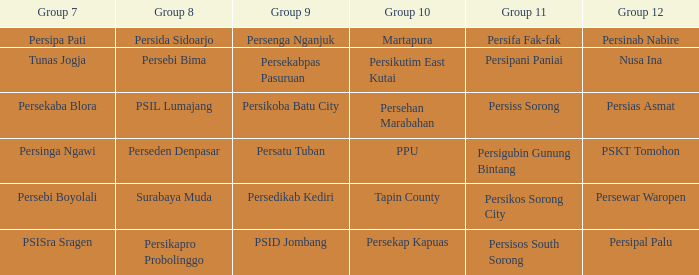When  persikos sorong city played in group 11, who played in group 7? Persebi Boyolali. 